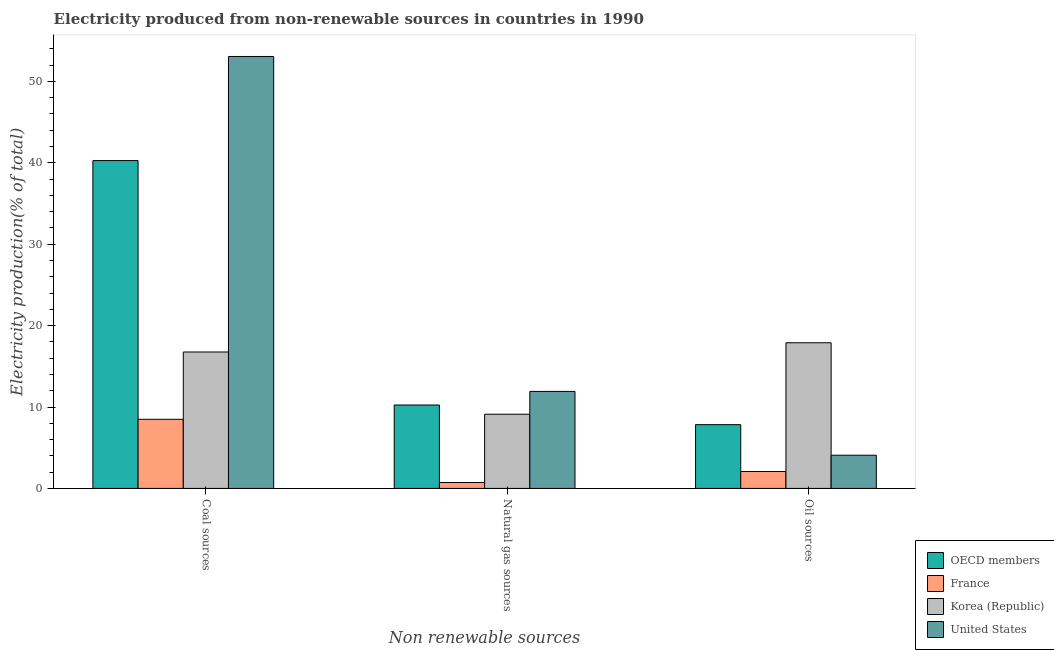How many different coloured bars are there?
Offer a very short reply. 4. How many groups of bars are there?
Keep it short and to the point. 3. How many bars are there on the 1st tick from the left?
Ensure brevity in your answer.  4. How many bars are there on the 2nd tick from the right?
Provide a short and direct response. 4. What is the label of the 1st group of bars from the left?
Offer a terse response. Coal sources. What is the percentage of electricity produced by coal in United States?
Make the answer very short. 53.07. Across all countries, what is the maximum percentage of electricity produced by oil sources?
Offer a terse response. 17.9. Across all countries, what is the minimum percentage of electricity produced by natural gas?
Your response must be concise. 0.73. What is the total percentage of electricity produced by oil sources in the graph?
Offer a very short reply. 31.89. What is the difference between the percentage of electricity produced by coal in Korea (Republic) and that in France?
Keep it short and to the point. 8.27. What is the difference between the percentage of electricity produced by oil sources in OECD members and the percentage of electricity produced by natural gas in United States?
Give a very brief answer. -4.08. What is the average percentage of electricity produced by natural gas per country?
Provide a short and direct response. 8. What is the difference between the percentage of electricity produced by coal and percentage of electricity produced by oil sources in France?
Ensure brevity in your answer.  6.41. What is the ratio of the percentage of electricity produced by coal in France to that in Korea (Republic)?
Keep it short and to the point. 0.51. Is the difference between the percentage of electricity produced by oil sources in France and United States greater than the difference between the percentage of electricity produced by coal in France and United States?
Offer a very short reply. Yes. What is the difference between the highest and the second highest percentage of electricity produced by oil sources?
Your response must be concise. 10.06. What is the difference between the highest and the lowest percentage of electricity produced by coal?
Give a very brief answer. 44.58. In how many countries, is the percentage of electricity produced by coal greater than the average percentage of electricity produced by coal taken over all countries?
Offer a very short reply. 2. Is the sum of the percentage of electricity produced by coal in France and Korea (Republic) greater than the maximum percentage of electricity produced by natural gas across all countries?
Your answer should be very brief. Yes. What does the 3rd bar from the left in Coal sources represents?
Offer a terse response. Korea (Republic). What does the 2nd bar from the right in Coal sources represents?
Ensure brevity in your answer.  Korea (Republic). How many countries are there in the graph?
Your answer should be very brief. 4. Are the values on the major ticks of Y-axis written in scientific E-notation?
Offer a terse response. No. Where does the legend appear in the graph?
Give a very brief answer. Bottom right. How are the legend labels stacked?
Provide a short and direct response. Vertical. What is the title of the graph?
Keep it short and to the point. Electricity produced from non-renewable sources in countries in 1990. What is the label or title of the X-axis?
Give a very brief answer. Non renewable sources. What is the label or title of the Y-axis?
Your answer should be compact. Electricity production(% of total). What is the Electricity production(% of total) of OECD members in Coal sources?
Keep it short and to the point. 40.28. What is the Electricity production(% of total) in France in Coal sources?
Provide a short and direct response. 8.49. What is the Electricity production(% of total) in Korea (Republic) in Coal sources?
Give a very brief answer. 16.76. What is the Electricity production(% of total) in United States in Coal sources?
Your answer should be very brief. 53.07. What is the Electricity production(% of total) in OECD members in Natural gas sources?
Keep it short and to the point. 10.25. What is the Electricity production(% of total) in France in Natural gas sources?
Your response must be concise. 0.73. What is the Electricity production(% of total) of Korea (Republic) in Natural gas sources?
Ensure brevity in your answer.  9.11. What is the Electricity production(% of total) in United States in Natural gas sources?
Keep it short and to the point. 11.92. What is the Electricity production(% of total) in OECD members in Oil sources?
Offer a terse response. 7.83. What is the Electricity production(% of total) of France in Oil sources?
Keep it short and to the point. 2.08. What is the Electricity production(% of total) in Korea (Republic) in Oil sources?
Make the answer very short. 17.9. What is the Electricity production(% of total) in United States in Oil sources?
Offer a very short reply. 4.08. Across all Non renewable sources, what is the maximum Electricity production(% of total) of OECD members?
Offer a very short reply. 40.28. Across all Non renewable sources, what is the maximum Electricity production(% of total) of France?
Give a very brief answer. 8.49. Across all Non renewable sources, what is the maximum Electricity production(% of total) of Korea (Republic)?
Give a very brief answer. 17.9. Across all Non renewable sources, what is the maximum Electricity production(% of total) in United States?
Offer a terse response. 53.07. Across all Non renewable sources, what is the minimum Electricity production(% of total) of OECD members?
Make the answer very short. 7.83. Across all Non renewable sources, what is the minimum Electricity production(% of total) in France?
Your answer should be very brief. 0.73. Across all Non renewable sources, what is the minimum Electricity production(% of total) in Korea (Republic)?
Your answer should be compact. 9.11. Across all Non renewable sources, what is the minimum Electricity production(% of total) in United States?
Keep it short and to the point. 4.08. What is the total Electricity production(% of total) of OECD members in the graph?
Keep it short and to the point. 58.36. What is the total Electricity production(% of total) of France in the graph?
Your answer should be compact. 11.29. What is the total Electricity production(% of total) of Korea (Republic) in the graph?
Provide a short and direct response. 43.77. What is the total Electricity production(% of total) in United States in the graph?
Provide a succinct answer. 69.06. What is the difference between the Electricity production(% of total) of OECD members in Coal sources and that in Natural gas sources?
Keep it short and to the point. 30.03. What is the difference between the Electricity production(% of total) of France in Coal sources and that in Natural gas sources?
Make the answer very short. 7.77. What is the difference between the Electricity production(% of total) of Korea (Republic) in Coal sources and that in Natural gas sources?
Keep it short and to the point. 7.65. What is the difference between the Electricity production(% of total) of United States in Coal sources and that in Natural gas sources?
Provide a succinct answer. 41.15. What is the difference between the Electricity production(% of total) of OECD members in Coal sources and that in Oil sources?
Your response must be concise. 32.44. What is the difference between the Electricity production(% of total) of France in Coal sources and that in Oil sources?
Make the answer very short. 6.41. What is the difference between the Electricity production(% of total) in Korea (Republic) in Coal sources and that in Oil sources?
Provide a short and direct response. -1.14. What is the difference between the Electricity production(% of total) in United States in Coal sources and that in Oil sources?
Give a very brief answer. 48.99. What is the difference between the Electricity production(% of total) in OECD members in Natural gas sources and that in Oil sources?
Offer a very short reply. 2.41. What is the difference between the Electricity production(% of total) of France in Natural gas sources and that in Oil sources?
Keep it short and to the point. -1.35. What is the difference between the Electricity production(% of total) in Korea (Republic) in Natural gas sources and that in Oil sources?
Give a very brief answer. -8.78. What is the difference between the Electricity production(% of total) in United States in Natural gas sources and that in Oil sources?
Give a very brief answer. 7.84. What is the difference between the Electricity production(% of total) in OECD members in Coal sources and the Electricity production(% of total) in France in Natural gas sources?
Your response must be concise. 39.55. What is the difference between the Electricity production(% of total) of OECD members in Coal sources and the Electricity production(% of total) of Korea (Republic) in Natural gas sources?
Give a very brief answer. 31.16. What is the difference between the Electricity production(% of total) of OECD members in Coal sources and the Electricity production(% of total) of United States in Natural gas sources?
Provide a succinct answer. 28.36. What is the difference between the Electricity production(% of total) in France in Coal sources and the Electricity production(% of total) in Korea (Republic) in Natural gas sources?
Your answer should be compact. -0.62. What is the difference between the Electricity production(% of total) of France in Coal sources and the Electricity production(% of total) of United States in Natural gas sources?
Make the answer very short. -3.43. What is the difference between the Electricity production(% of total) in Korea (Republic) in Coal sources and the Electricity production(% of total) in United States in Natural gas sources?
Provide a short and direct response. 4.84. What is the difference between the Electricity production(% of total) of OECD members in Coal sources and the Electricity production(% of total) of France in Oil sources?
Offer a very short reply. 38.2. What is the difference between the Electricity production(% of total) in OECD members in Coal sources and the Electricity production(% of total) in Korea (Republic) in Oil sources?
Provide a short and direct response. 22.38. What is the difference between the Electricity production(% of total) in OECD members in Coal sources and the Electricity production(% of total) in United States in Oil sources?
Provide a short and direct response. 36.2. What is the difference between the Electricity production(% of total) of France in Coal sources and the Electricity production(% of total) of Korea (Republic) in Oil sources?
Provide a short and direct response. -9.41. What is the difference between the Electricity production(% of total) in France in Coal sources and the Electricity production(% of total) in United States in Oil sources?
Give a very brief answer. 4.41. What is the difference between the Electricity production(% of total) in Korea (Republic) in Coal sources and the Electricity production(% of total) in United States in Oil sources?
Offer a very short reply. 12.68. What is the difference between the Electricity production(% of total) in OECD members in Natural gas sources and the Electricity production(% of total) in France in Oil sources?
Your answer should be very brief. 8.17. What is the difference between the Electricity production(% of total) of OECD members in Natural gas sources and the Electricity production(% of total) of Korea (Republic) in Oil sources?
Offer a very short reply. -7.65. What is the difference between the Electricity production(% of total) of OECD members in Natural gas sources and the Electricity production(% of total) of United States in Oil sources?
Ensure brevity in your answer.  6.17. What is the difference between the Electricity production(% of total) of France in Natural gas sources and the Electricity production(% of total) of Korea (Republic) in Oil sources?
Offer a terse response. -17.17. What is the difference between the Electricity production(% of total) in France in Natural gas sources and the Electricity production(% of total) in United States in Oil sources?
Give a very brief answer. -3.35. What is the difference between the Electricity production(% of total) of Korea (Republic) in Natural gas sources and the Electricity production(% of total) of United States in Oil sources?
Your response must be concise. 5.04. What is the average Electricity production(% of total) in OECD members per Non renewable sources?
Give a very brief answer. 19.45. What is the average Electricity production(% of total) of France per Non renewable sources?
Your answer should be compact. 3.76. What is the average Electricity production(% of total) of Korea (Republic) per Non renewable sources?
Your answer should be compact. 14.59. What is the average Electricity production(% of total) in United States per Non renewable sources?
Your answer should be very brief. 23.02. What is the difference between the Electricity production(% of total) of OECD members and Electricity production(% of total) of France in Coal sources?
Offer a terse response. 31.79. What is the difference between the Electricity production(% of total) of OECD members and Electricity production(% of total) of Korea (Republic) in Coal sources?
Make the answer very short. 23.52. What is the difference between the Electricity production(% of total) in OECD members and Electricity production(% of total) in United States in Coal sources?
Offer a terse response. -12.79. What is the difference between the Electricity production(% of total) of France and Electricity production(% of total) of Korea (Republic) in Coal sources?
Your answer should be compact. -8.27. What is the difference between the Electricity production(% of total) of France and Electricity production(% of total) of United States in Coal sources?
Provide a succinct answer. -44.58. What is the difference between the Electricity production(% of total) of Korea (Republic) and Electricity production(% of total) of United States in Coal sources?
Your answer should be compact. -36.31. What is the difference between the Electricity production(% of total) in OECD members and Electricity production(% of total) in France in Natural gas sources?
Ensure brevity in your answer.  9.52. What is the difference between the Electricity production(% of total) of OECD members and Electricity production(% of total) of Korea (Republic) in Natural gas sources?
Provide a succinct answer. 1.13. What is the difference between the Electricity production(% of total) in OECD members and Electricity production(% of total) in United States in Natural gas sources?
Your answer should be compact. -1.67. What is the difference between the Electricity production(% of total) of France and Electricity production(% of total) of Korea (Republic) in Natural gas sources?
Your answer should be compact. -8.39. What is the difference between the Electricity production(% of total) of France and Electricity production(% of total) of United States in Natural gas sources?
Provide a short and direct response. -11.19. What is the difference between the Electricity production(% of total) in Korea (Republic) and Electricity production(% of total) in United States in Natural gas sources?
Keep it short and to the point. -2.8. What is the difference between the Electricity production(% of total) of OECD members and Electricity production(% of total) of France in Oil sources?
Your response must be concise. 5.76. What is the difference between the Electricity production(% of total) of OECD members and Electricity production(% of total) of Korea (Republic) in Oil sources?
Ensure brevity in your answer.  -10.06. What is the difference between the Electricity production(% of total) in OECD members and Electricity production(% of total) in United States in Oil sources?
Offer a very short reply. 3.75. What is the difference between the Electricity production(% of total) in France and Electricity production(% of total) in Korea (Republic) in Oil sources?
Your answer should be very brief. -15.82. What is the difference between the Electricity production(% of total) of France and Electricity production(% of total) of United States in Oil sources?
Your answer should be compact. -2. What is the difference between the Electricity production(% of total) of Korea (Republic) and Electricity production(% of total) of United States in Oil sources?
Make the answer very short. 13.82. What is the ratio of the Electricity production(% of total) in OECD members in Coal sources to that in Natural gas sources?
Your answer should be compact. 3.93. What is the ratio of the Electricity production(% of total) of France in Coal sources to that in Natural gas sources?
Keep it short and to the point. 11.7. What is the ratio of the Electricity production(% of total) in Korea (Republic) in Coal sources to that in Natural gas sources?
Offer a very short reply. 1.84. What is the ratio of the Electricity production(% of total) in United States in Coal sources to that in Natural gas sources?
Offer a very short reply. 4.45. What is the ratio of the Electricity production(% of total) of OECD members in Coal sources to that in Oil sources?
Your answer should be compact. 5.14. What is the ratio of the Electricity production(% of total) in France in Coal sources to that in Oil sources?
Offer a very short reply. 4.09. What is the ratio of the Electricity production(% of total) of Korea (Republic) in Coal sources to that in Oil sources?
Make the answer very short. 0.94. What is the ratio of the Electricity production(% of total) of United States in Coal sources to that in Oil sources?
Offer a very short reply. 13.01. What is the ratio of the Electricity production(% of total) in OECD members in Natural gas sources to that in Oil sources?
Ensure brevity in your answer.  1.31. What is the ratio of the Electricity production(% of total) in France in Natural gas sources to that in Oil sources?
Provide a short and direct response. 0.35. What is the ratio of the Electricity production(% of total) in Korea (Republic) in Natural gas sources to that in Oil sources?
Your answer should be very brief. 0.51. What is the ratio of the Electricity production(% of total) of United States in Natural gas sources to that in Oil sources?
Provide a short and direct response. 2.92. What is the difference between the highest and the second highest Electricity production(% of total) in OECD members?
Give a very brief answer. 30.03. What is the difference between the highest and the second highest Electricity production(% of total) in France?
Your answer should be compact. 6.41. What is the difference between the highest and the second highest Electricity production(% of total) of Korea (Republic)?
Offer a terse response. 1.14. What is the difference between the highest and the second highest Electricity production(% of total) of United States?
Offer a terse response. 41.15. What is the difference between the highest and the lowest Electricity production(% of total) in OECD members?
Offer a terse response. 32.44. What is the difference between the highest and the lowest Electricity production(% of total) of France?
Your response must be concise. 7.77. What is the difference between the highest and the lowest Electricity production(% of total) of Korea (Republic)?
Provide a succinct answer. 8.78. What is the difference between the highest and the lowest Electricity production(% of total) of United States?
Your response must be concise. 48.99. 